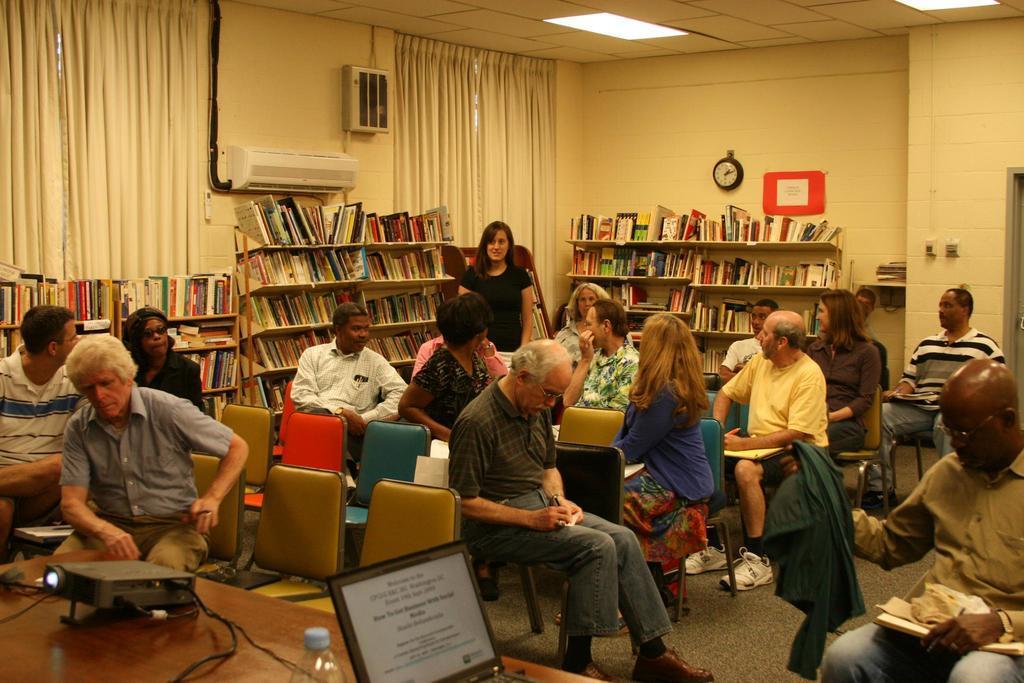Describe this image in one or two sentences. In this image, we can see people sitting on the chairs and are holding some objects and we can see a bottle, a laptop and some objects on the stand. In the background, there are books in the rack and we can see an air conditioner, a clock, a board and there is an object on the wall and we can see curtains. At the top, there are lights and at the bottom, there is a floor. 